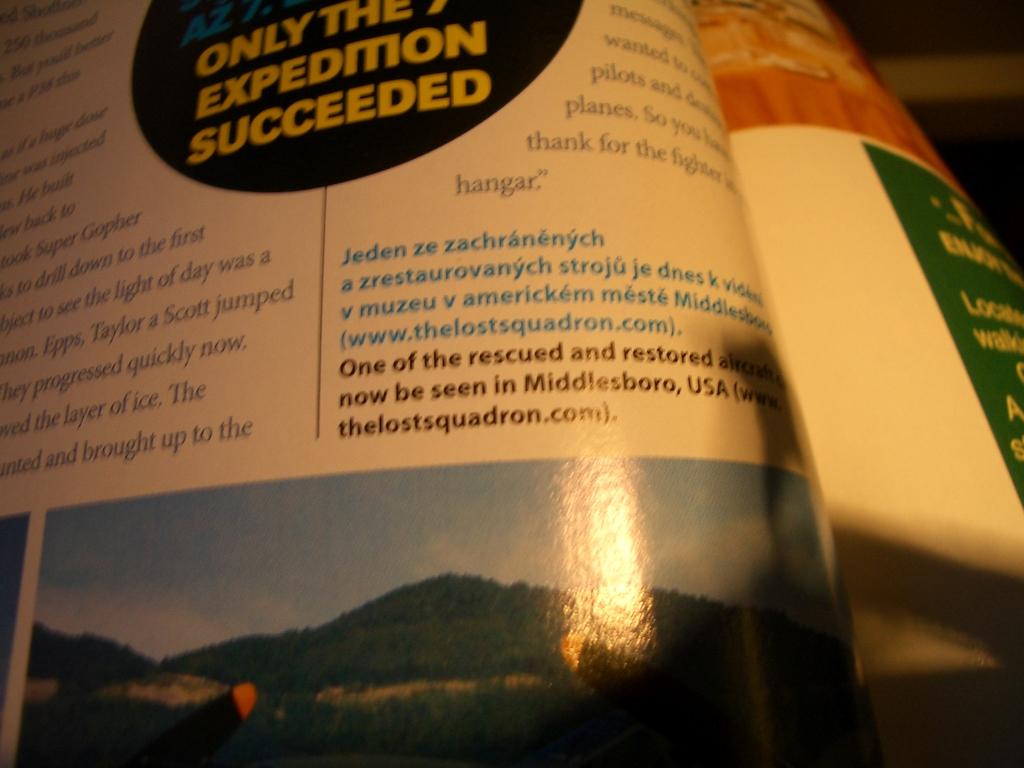Does it say the expedition succeeded?
Offer a very short reply. Yes. 